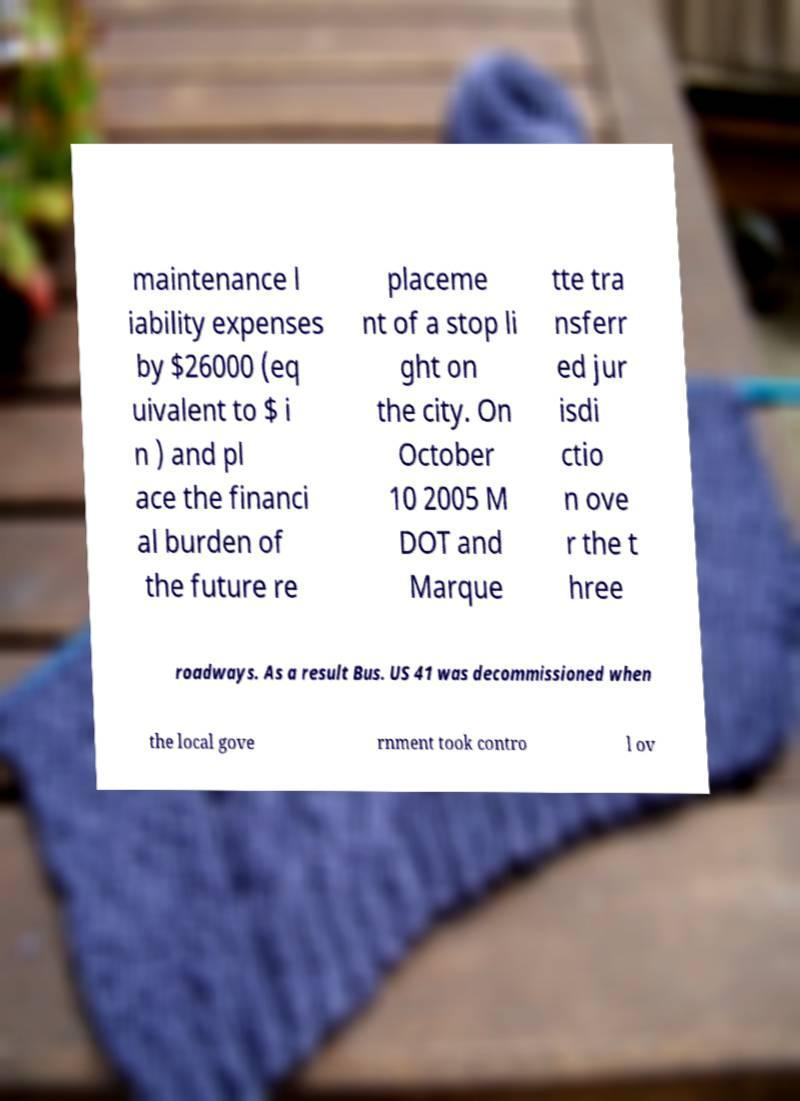What messages or text are displayed in this image? I need them in a readable, typed format. maintenance l iability expenses by $26000 (eq uivalent to $ i n ) and pl ace the financi al burden of the future re placeme nt of a stop li ght on the city. On October 10 2005 M DOT and Marque tte tra nsferr ed jur isdi ctio n ove r the t hree roadways. As a result Bus. US 41 was decommissioned when the local gove rnment took contro l ov 